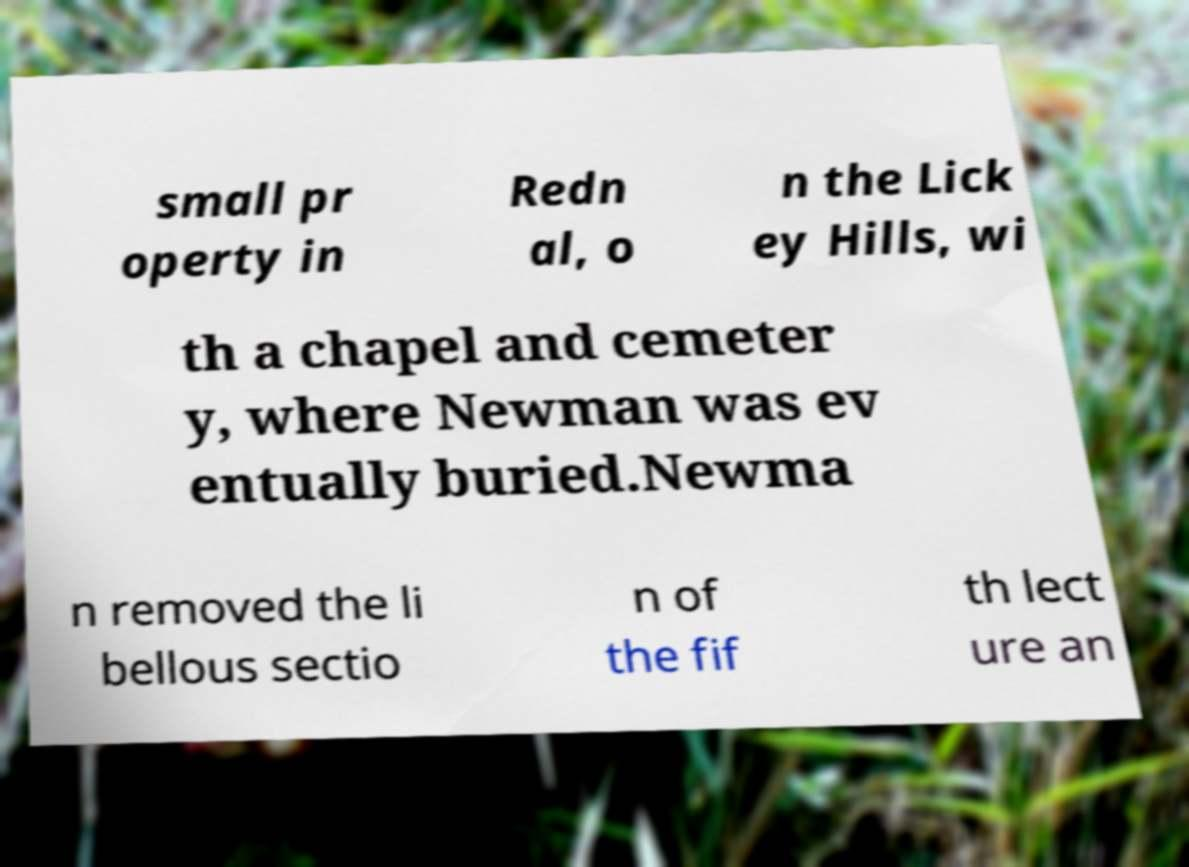Could you extract and type out the text from this image? small pr operty in Redn al, o n the Lick ey Hills, wi th a chapel and cemeter y, where Newman was ev entually buried.Newma n removed the li bellous sectio n of the fif th lect ure an 